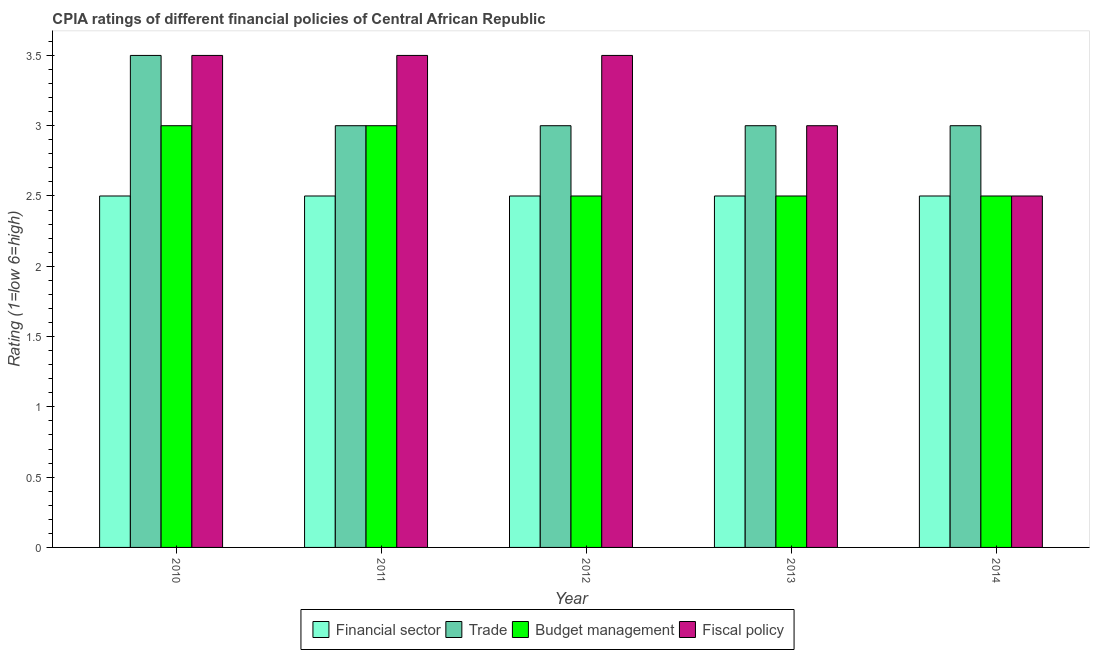How many groups of bars are there?
Ensure brevity in your answer.  5. How many bars are there on the 3rd tick from the right?
Provide a short and direct response. 4. In how many cases, is the number of bars for a given year not equal to the number of legend labels?
Give a very brief answer. 0. Across all years, what is the maximum cpia rating of fiscal policy?
Keep it short and to the point. 3.5. In which year was the cpia rating of budget management minimum?
Your response must be concise. 2012. What is the total cpia rating of trade in the graph?
Make the answer very short. 15.5. What is the difference between the cpia rating of budget management in 2010 and the cpia rating of trade in 2012?
Ensure brevity in your answer.  0.5. In the year 2013, what is the difference between the cpia rating of budget management and cpia rating of financial sector?
Ensure brevity in your answer.  0. What is the ratio of the cpia rating of financial sector in 2012 to that in 2013?
Your answer should be compact. 1. Is the cpia rating of financial sector in 2010 less than that in 2012?
Your response must be concise. No. What is the difference between the highest and the second highest cpia rating of trade?
Provide a succinct answer. 0.5. In how many years, is the cpia rating of financial sector greater than the average cpia rating of financial sector taken over all years?
Your answer should be very brief. 0. What does the 3rd bar from the left in 2012 represents?
Give a very brief answer. Budget management. What does the 1st bar from the right in 2011 represents?
Keep it short and to the point. Fiscal policy. Are all the bars in the graph horizontal?
Keep it short and to the point. No. How many years are there in the graph?
Ensure brevity in your answer.  5. Does the graph contain grids?
Provide a short and direct response. No. Where does the legend appear in the graph?
Provide a succinct answer. Bottom center. How many legend labels are there?
Keep it short and to the point. 4. How are the legend labels stacked?
Your answer should be compact. Horizontal. What is the title of the graph?
Offer a very short reply. CPIA ratings of different financial policies of Central African Republic. What is the label or title of the Y-axis?
Offer a terse response. Rating (1=low 6=high). What is the Rating (1=low 6=high) in Financial sector in 2010?
Your response must be concise. 2.5. What is the Rating (1=low 6=high) of Trade in 2010?
Offer a very short reply. 3.5. What is the Rating (1=low 6=high) in Fiscal policy in 2010?
Provide a succinct answer. 3.5. What is the Rating (1=low 6=high) in Financial sector in 2011?
Ensure brevity in your answer.  2.5. What is the Rating (1=low 6=high) of Trade in 2011?
Ensure brevity in your answer.  3. What is the Rating (1=low 6=high) of Budget management in 2011?
Offer a very short reply. 3. What is the Rating (1=low 6=high) in Fiscal policy in 2011?
Make the answer very short. 3.5. What is the Rating (1=low 6=high) in Financial sector in 2012?
Offer a terse response. 2.5. What is the Rating (1=low 6=high) in Trade in 2012?
Ensure brevity in your answer.  3. What is the Rating (1=low 6=high) in Budget management in 2012?
Offer a very short reply. 2.5. What is the Rating (1=low 6=high) in Fiscal policy in 2013?
Your answer should be compact. 3. What is the Rating (1=low 6=high) of Financial sector in 2014?
Ensure brevity in your answer.  2.5. What is the Rating (1=low 6=high) of Budget management in 2014?
Provide a succinct answer. 2.5. Across all years, what is the maximum Rating (1=low 6=high) in Financial sector?
Make the answer very short. 2.5. Across all years, what is the maximum Rating (1=low 6=high) of Budget management?
Ensure brevity in your answer.  3. Across all years, what is the minimum Rating (1=low 6=high) of Financial sector?
Your answer should be compact. 2.5. Across all years, what is the minimum Rating (1=low 6=high) of Trade?
Provide a succinct answer. 3. What is the total Rating (1=low 6=high) of Budget management in the graph?
Offer a terse response. 13.5. What is the total Rating (1=low 6=high) in Fiscal policy in the graph?
Your answer should be compact. 16. What is the difference between the Rating (1=low 6=high) of Financial sector in 2010 and that in 2011?
Your answer should be very brief. 0. What is the difference between the Rating (1=low 6=high) of Budget management in 2010 and that in 2011?
Provide a succinct answer. 0. What is the difference between the Rating (1=low 6=high) in Fiscal policy in 2010 and that in 2011?
Your response must be concise. 0. What is the difference between the Rating (1=low 6=high) of Financial sector in 2010 and that in 2013?
Ensure brevity in your answer.  0. What is the difference between the Rating (1=low 6=high) of Trade in 2010 and that in 2013?
Ensure brevity in your answer.  0.5. What is the difference between the Rating (1=low 6=high) of Fiscal policy in 2010 and that in 2014?
Provide a short and direct response. 1. What is the difference between the Rating (1=low 6=high) in Budget management in 2011 and that in 2012?
Provide a short and direct response. 0.5. What is the difference between the Rating (1=low 6=high) of Fiscal policy in 2011 and that in 2012?
Your response must be concise. 0. What is the difference between the Rating (1=low 6=high) in Financial sector in 2011 and that in 2013?
Your response must be concise. 0. What is the difference between the Rating (1=low 6=high) of Trade in 2011 and that in 2013?
Keep it short and to the point. 0. What is the difference between the Rating (1=low 6=high) in Trade in 2011 and that in 2014?
Provide a succinct answer. 0. What is the difference between the Rating (1=low 6=high) in Financial sector in 2012 and that in 2013?
Ensure brevity in your answer.  0. What is the difference between the Rating (1=low 6=high) in Financial sector in 2012 and that in 2014?
Give a very brief answer. 0. What is the difference between the Rating (1=low 6=high) of Trade in 2012 and that in 2014?
Keep it short and to the point. 0. What is the difference between the Rating (1=low 6=high) of Budget management in 2012 and that in 2014?
Offer a terse response. 0. What is the difference between the Rating (1=low 6=high) in Trade in 2013 and that in 2014?
Provide a succinct answer. 0. What is the difference between the Rating (1=low 6=high) in Budget management in 2013 and that in 2014?
Keep it short and to the point. 0. What is the difference between the Rating (1=low 6=high) in Fiscal policy in 2013 and that in 2014?
Offer a very short reply. 0.5. What is the difference between the Rating (1=low 6=high) of Financial sector in 2010 and the Rating (1=low 6=high) of Trade in 2011?
Make the answer very short. -0.5. What is the difference between the Rating (1=low 6=high) of Financial sector in 2010 and the Rating (1=low 6=high) of Fiscal policy in 2011?
Keep it short and to the point. -1. What is the difference between the Rating (1=low 6=high) in Trade in 2010 and the Rating (1=low 6=high) in Budget management in 2011?
Your answer should be compact. 0.5. What is the difference between the Rating (1=low 6=high) of Trade in 2010 and the Rating (1=low 6=high) of Fiscal policy in 2011?
Your answer should be very brief. 0. What is the difference between the Rating (1=low 6=high) in Trade in 2010 and the Rating (1=low 6=high) in Fiscal policy in 2012?
Make the answer very short. 0. What is the difference between the Rating (1=low 6=high) in Budget management in 2010 and the Rating (1=low 6=high) in Fiscal policy in 2012?
Your response must be concise. -0.5. What is the difference between the Rating (1=low 6=high) of Financial sector in 2010 and the Rating (1=low 6=high) of Budget management in 2013?
Provide a succinct answer. 0. What is the difference between the Rating (1=low 6=high) in Financial sector in 2010 and the Rating (1=low 6=high) in Fiscal policy in 2013?
Provide a succinct answer. -0.5. What is the difference between the Rating (1=low 6=high) in Financial sector in 2010 and the Rating (1=low 6=high) in Fiscal policy in 2014?
Provide a short and direct response. 0. What is the difference between the Rating (1=low 6=high) of Trade in 2010 and the Rating (1=low 6=high) of Budget management in 2014?
Offer a terse response. 1. What is the difference between the Rating (1=low 6=high) in Trade in 2010 and the Rating (1=low 6=high) in Fiscal policy in 2014?
Provide a succinct answer. 1. What is the difference between the Rating (1=low 6=high) in Financial sector in 2011 and the Rating (1=low 6=high) in Fiscal policy in 2012?
Keep it short and to the point. -1. What is the difference between the Rating (1=low 6=high) in Trade in 2011 and the Rating (1=low 6=high) in Budget management in 2012?
Offer a very short reply. 0.5. What is the difference between the Rating (1=low 6=high) in Financial sector in 2011 and the Rating (1=low 6=high) in Trade in 2013?
Ensure brevity in your answer.  -0.5. What is the difference between the Rating (1=low 6=high) in Financial sector in 2011 and the Rating (1=low 6=high) in Fiscal policy in 2013?
Your answer should be very brief. -0.5. What is the difference between the Rating (1=low 6=high) of Trade in 2011 and the Rating (1=low 6=high) of Fiscal policy in 2013?
Provide a succinct answer. 0. What is the difference between the Rating (1=low 6=high) in Budget management in 2011 and the Rating (1=low 6=high) in Fiscal policy in 2013?
Give a very brief answer. 0. What is the difference between the Rating (1=low 6=high) in Financial sector in 2011 and the Rating (1=low 6=high) in Trade in 2014?
Give a very brief answer. -0.5. What is the difference between the Rating (1=low 6=high) in Financial sector in 2011 and the Rating (1=low 6=high) in Budget management in 2014?
Your answer should be very brief. 0. What is the difference between the Rating (1=low 6=high) of Trade in 2011 and the Rating (1=low 6=high) of Fiscal policy in 2014?
Offer a very short reply. 0.5. What is the difference between the Rating (1=low 6=high) of Budget management in 2011 and the Rating (1=low 6=high) of Fiscal policy in 2014?
Your response must be concise. 0.5. What is the difference between the Rating (1=low 6=high) of Financial sector in 2012 and the Rating (1=low 6=high) of Trade in 2013?
Make the answer very short. -0.5. What is the difference between the Rating (1=low 6=high) in Financial sector in 2012 and the Rating (1=low 6=high) in Budget management in 2013?
Your response must be concise. 0. What is the difference between the Rating (1=low 6=high) of Trade in 2012 and the Rating (1=low 6=high) of Fiscal policy in 2013?
Your answer should be compact. 0. What is the difference between the Rating (1=low 6=high) of Financial sector in 2012 and the Rating (1=low 6=high) of Trade in 2014?
Offer a very short reply. -0.5. What is the difference between the Rating (1=low 6=high) in Financial sector in 2012 and the Rating (1=low 6=high) in Fiscal policy in 2014?
Make the answer very short. 0. What is the difference between the Rating (1=low 6=high) of Trade in 2012 and the Rating (1=low 6=high) of Budget management in 2014?
Your response must be concise. 0.5. What is the difference between the Rating (1=low 6=high) in Trade in 2012 and the Rating (1=low 6=high) in Fiscal policy in 2014?
Offer a terse response. 0.5. What is the difference between the Rating (1=low 6=high) of Budget management in 2012 and the Rating (1=low 6=high) of Fiscal policy in 2014?
Make the answer very short. 0. What is the difference between the Rating (1=low 6=high) in Financial sector in 2013 and the Rating (1=low 6=high) in Budget management in 2014?
Keep it short and to the point. 0. What is the difference between the Rating (1=low 6=high) in Trade in 2013 and the Rating (1=low 6=high) in Budget management in 2014?
Offer a very short reply. 0.5. What is the difference between the Rating (1=low 6=high) of Budget management in 2013 and the Rating (1=low 6=high) of Fiscal policy in 2014?
Keep it short and to the point. 0. What is the average Rating (1=low 6=high) in Trade per year?
Make the answer very short. 3.1. What is the average Rating (1=low 6=high) of Budget management per year?
Offer a very short reply. 2.7. What is the average Rating (1=low 6=high) of Fiscal policy per year?
Make the answer very short. 3.2. In the year 2010, what is the difference between the Rating (1=low 6=high) of Financial sector and Rating (1=low 6=high) of Budget management?
Your answer should be very brief. -0.5. In the year 2010, what is the difference between the Rating (1=low 6=high) in Trade and Rating (1=low 6=high) in Budget management?
Offer a very short reply. 0.5. In the year 2011, what is the difference between the Rating (1=low 6=high) in Financial sector and Rating (1=low 6=high) in Trade?
Keep it short and to the point. -0.5. In the year 2011, what is the difference between the Rating (1=low 6=high) in Financial sector and Rating (1=low 6=high) in Budget management?
Give a very brief answer. -0.5. In the year 2011, what is the difference between the Rating (1=low 6=high) in Financial sector and Rating (1=low 6=high) in Fiscal policy?
Provide a short and direct response. -1. In the year 2011, what is the difference between the Rating (1=low 6=high) of Trade and Rating (1=low 6=high) of Fiscal policy?
Your answer should be compact. -0.5. In the year 2011, what is the difference between the Rating (1=low 6=high) in Budget management and Rating (1=low 6=high) in Fiscal policy?
Your response must be concise. -0.5. In the year 2012, what is the difference between the Rating (1=low 6=high) in Financial sector and Rating (1=low 6=high) in Trade?
Your response must be concise. -0.5. In the year 2012, what is the difference between the Rating (1=low 6=high) in Financial sector and Rating (1=low 6=high) in Budget management?
Provide a short and direct response. 0. In the year 2012, what is the difference between the Rating (1=low 6=high) of Financial sector and Rating (1=low 6=high) of Fiscal policy?
Ensure brevity in your answer.  -1. In the year 2012, what is the difference between the Rating (1=low 6=high) of Trade and Rating (1=low 6=high) of Budget management?
Give a very brief answer. 0.5. In the year 2013, what is the difference between the Rating (1=low 6=high) in Financial sector and Rating (1=low 6=high) in Budget management?
Keep it short and to the point. 0. In the year 2013, what is the difference between the Rating (1=low 6=high) in Budget management and Rating (1=low 6=high) in Fiscal policy?
Your response must be concise. -0.5. In the year 2014, what is the difference between the Rating (1=low 6=high) in Financial sector and Rating (1=low 6=high) in Fiscal policy?
Offer a terse response. 0. In the year 2014, what is the difference between the Rating (1=low 6=high) in Trade and Rating (1=low 6=high) in Fiscal policy?
Your response must be concise. 0.5. What is the ratio of the Rating (1=low 6=high) in Financial sector in 2010 to that in 2011?
Offer a terse response. 1. What is the ratio of the Rating (1=low 6=high) in Trade in 2010 to that in 2011?
Make the answer very short. 1.17. What is the ratio of the Rating (1=low 6=high) in Budget management in 2010 to that in 2011?
Your answer should be compact. 1. What is the ratio of the Rating (1=low 6=high) in Fiscal policy in 2010 to that in 2011?
Provide a short and direct response. 1. What is the ratio of the Rating (1=low 6=high) of Budget management in 2010 to that in 2012?
Provide a short and direct response. 1.2. What is the ratio of the Rating (1=low 6=high) of Fiscal policy in 2010 to that in 2012?
Keep it short and to the point. 1. What is the ratio of the Rating (1=low 6=high) of Trade in 2010 to that in 2014?
Your answer should be compact. 1.17. What is the ratio of the Rating (1=low 6=high) in Budget management in 2010 to that in 2014?
Your response must be concise. 1.2. What is the ratio of the Rating (1=low 6=high) in Trade in 2011 to that in 2012?
Ensure brevity in your answer.  1. What is the ratio of the Rating (1=low 6=high) in Fiscal policy in 2011 to that in 2012?
Offer a very short reply. 1. What is the ratio of the Rating (1=low 6=high) of Financial sector in 2011 to that in 2013?
Give a very brief answer. 1. What is the ratio of the Rating (1=low 6=high) of Trade in 2012 to that in 2014?
Offer a very short reply. 1. What is the ratio of the Rating (1=low 6=high) of Budget management in 2012 to that in 2014?
Provide a succinct answer. 1. What is the ratio of the Rating (1=low 6=high) of Fiscal policy in 2012 to that in 2014?
Give a very brief answer. 1.4. What is the ratio of the Rating (1=low 6=high) of Financial sector in 2013 to that in 2014?
Offer a terse response. 1. What is the ratio of the Rating (1=low 6=high) of Trade in 2013 to that in 2014?
Ensure brevity in your answer.  1. What is the difference between the highest and the second highest Rating (1=low 6=high) in Financial sector?
Your response must be concise. 0. What is the difference between the highest and the second highest Rating (1=low 6=high) in Trade?
Provide a succinct answer. 0.5. What is the difference between the highest and the second highest Rating (1=low 6=high) of Budget management?
Offer a terse response. 0. What is the difference between the highest and the second highest Rating (1=low 6=high) in Fiscal policy?
Your answer should be compact. 0. What is the difference between the highest and the lowest Rating (1=low 6=high) in Financial sector?
Your answer should be compact. 0. What is the difference between the highest and the lowest Rating (1=low 6=high) in Trade?
Your response must be concise. 0.5. What is the difference between the highest and the lowest Rating (1=low 6=high) in Budget management?
Your response must be concise. 0.5. What is the difference between the highest and the lowest Rating (1=low 6=high) of Fiscal policy?
Give a very brief answer. 1. 